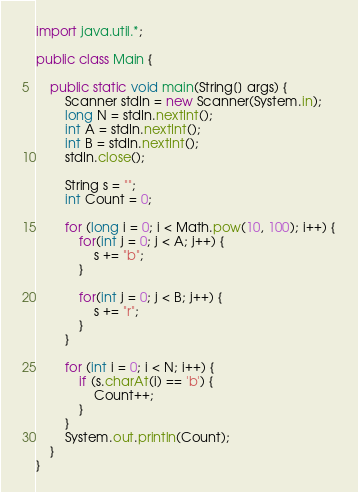<code> <loc_0><loc_0><loc_500><loc_500><_Java_>import java.util.*;

public class Main {

    public static void main(String[] args) {
        Scanner stdIn = new Scanner(System.in);
        long N = stdIn.nextInt();
        int A = stdIn.nextInt();
        int B = stdIn.nextInt();
        stdIn.close();

        String s = "";
        int Count = 0;

        for (long i = 0; i < Math.pow(10, 100); i++) {
            for(int j = 0; j < A; j++) {
                s += "b";
            }
    
            for(int j = 0; j < B; j++) {
                s += "r";
            }
        }
        
        for (int i = 0; i < N; i++) {
            if (s.charAt(i) == 'b') {
                Count++;
            }
        }
        System.out.println(Count);
    }
}</code> 